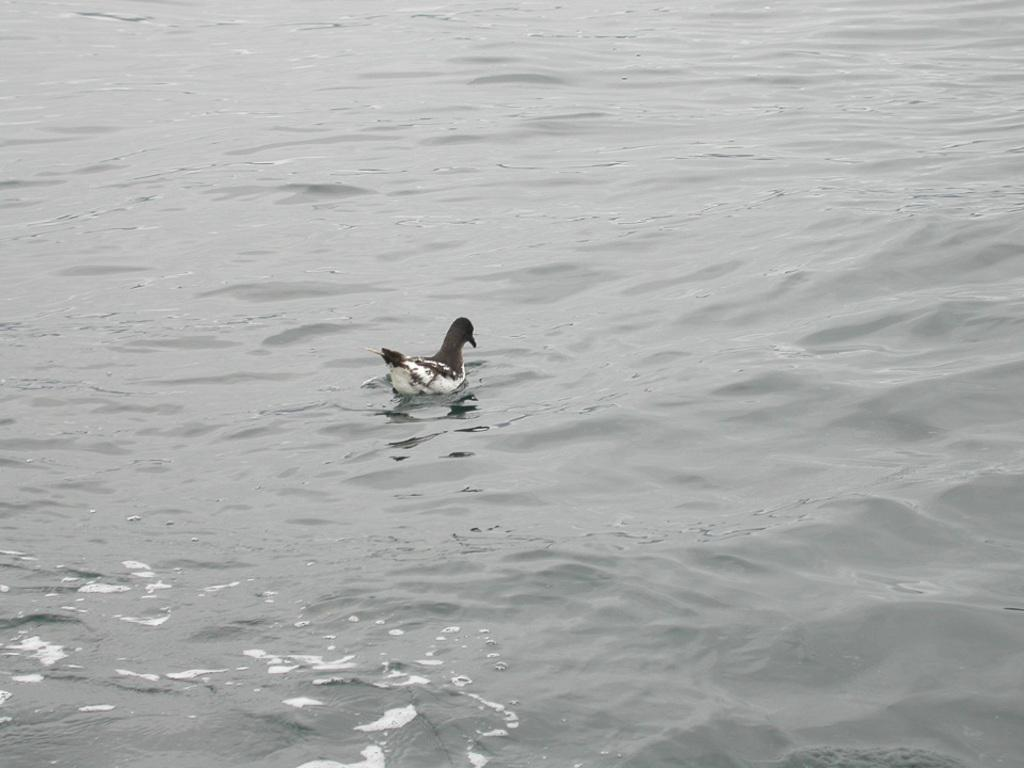What type of animal is in the image? There is a bird in the image. Where is the bird located? The bird is in the water. What colors can be seen on the bird? The bird is black and white in color. What type of son does the lawyer represent in the bedroom in the image? There is no son, lawyer, or bedroom present in the image; it features a bird in the water. 